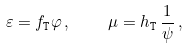Convert formula to latex. <formula><loc_0><loc_0><loc_500><loc_500>\varepsilon = { f _ { \tt T } } \varphi \, , \quad \mu = { h _ { \tt T } } \, \frac { 1 } { \psi } \, ,</formula> 